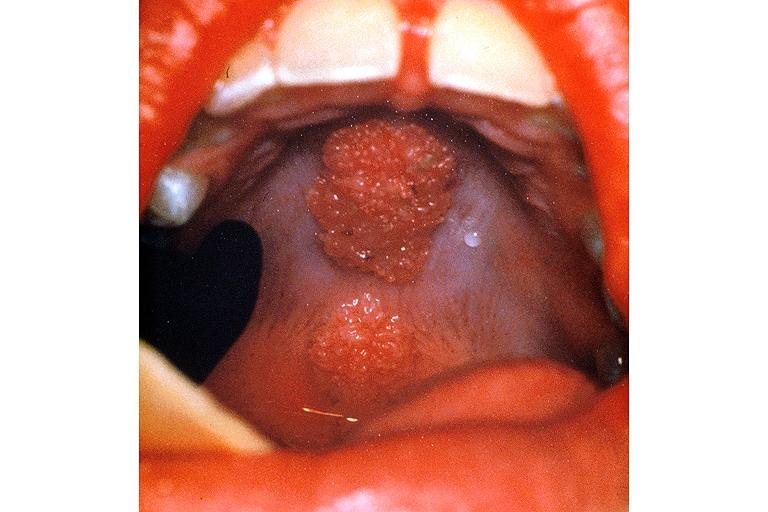where is this?
Answer the question using a single word or phrase. Oral 